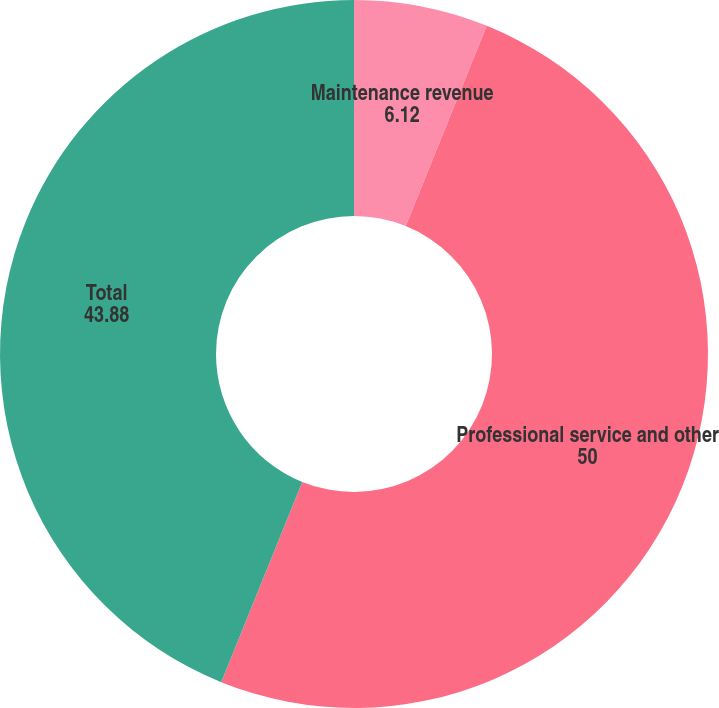Convert chart to OTSL. <chart><loc_0><loc_0><loc_500><loc_500><pie_chart><fcel>Maintenance revenue<fcel>Professional service and other<fcel>Total<nl><fcel>6.12%<fcel>50.0%<fcel>43.88%<nl></chart> 